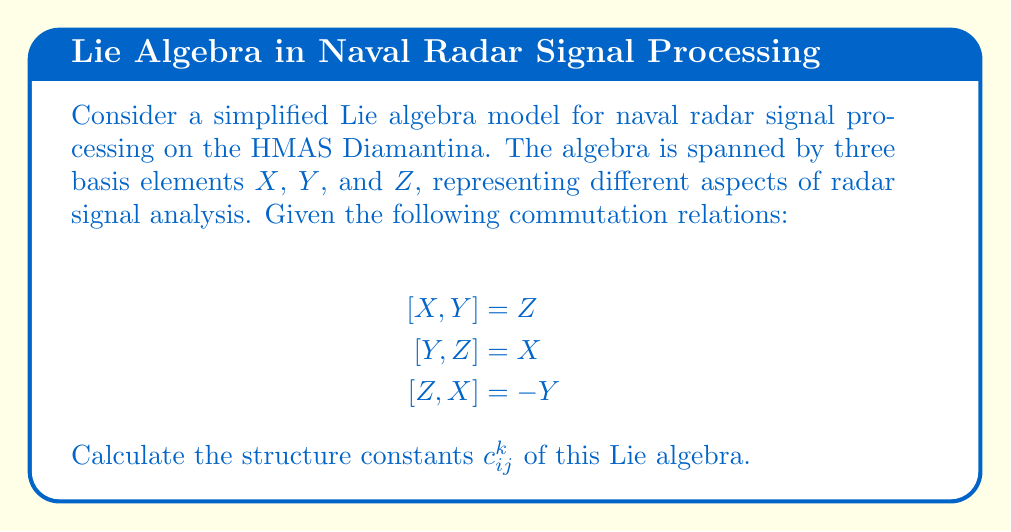Can you solve this math problem? To calculate the structure constants, we follow these steps:

1) The structure constants $c_{ij}^k$ are defined by the equation:

   $$[X_i, X_j] = \sum_k c_{ij}^k X_k$$

   where $X_i$, $X_j$, and $X_k$ are basis elements of the Lie algebra.

2) In our case, we have $X_1 = X$, $X_2 = Y$, and $X_3 = Z$.

3) Let's analyze each commutation relation:

   a) $[X, Y] = Z$ implies $c_{12}^3 = 1$ (and $c_{21}^3 = -1$ due to antisymmetry)
   b) $[Y, Z] = X$ implies $c_{23}^1 = 1$ (and $c_{32}^1 = -1$)
   c) $[Z, X] = -Y$ implies $c_{31}^2 = -1$ (and $c_{13}^2 = 1$)

4) All other structure constants are zero.

5) We can summarize the non-zero structure constants as:

   $$c_{12}^3 = -c_{21}^3 = 1$$
   $$c_{23}^1 = -c_{32}^1 = 1$$
   $$c_{31}^2 = -c_{13}^2 = -1$$

This set of structure constants fully defines the Lie algebra for this simplified radar signal processing model.
Answer: $c_{12}^3 = c_{23}^1 = 1$, $c_{31}^2 = -1$, and their antisymmetric counterparts; all others are zero. 